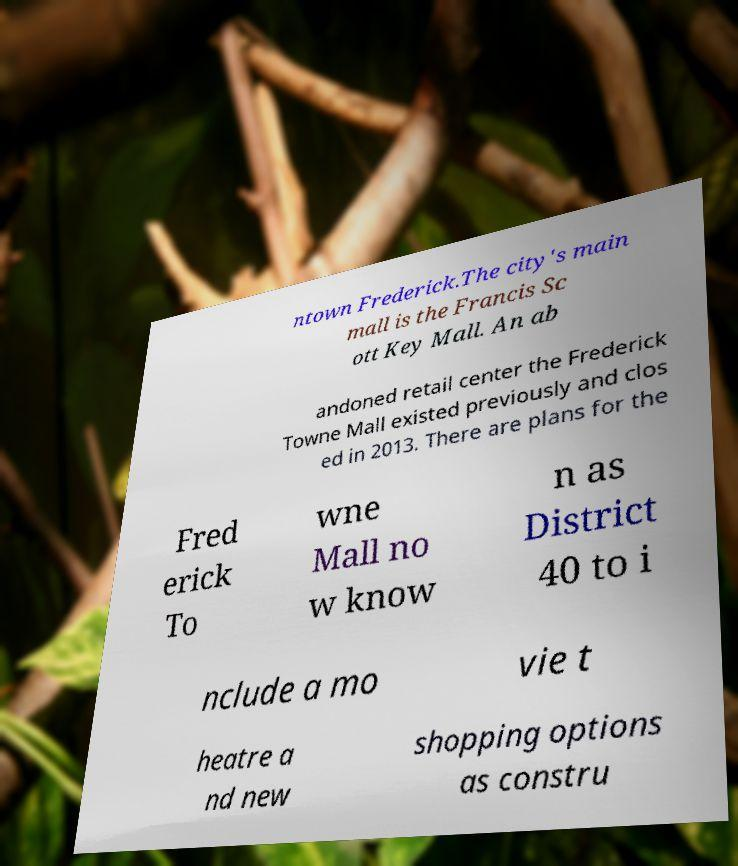What messages or text are displayed in this image? I need them in a readable, typed format. ntown Frederick.The city's main mall is the Francis Sc ott Key Mall. An ab andoned retail center the Frederick Towne Mall existed previously and clos ed in 2013. There are plans for the Fred erick To wne Mall no w know n as District 40 to i nclude a mo vie t heatre a nd new shopping options as constru 